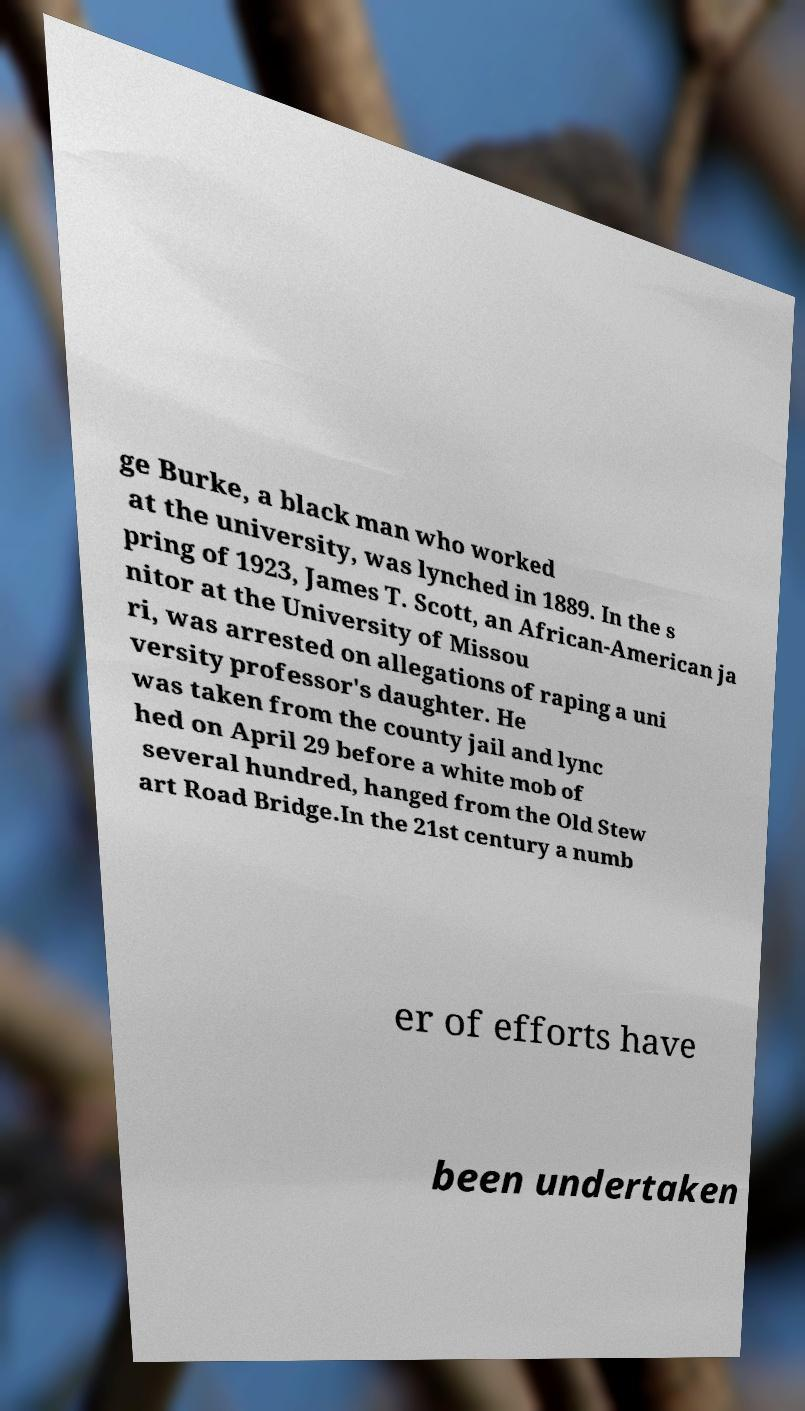Could you extract and type out the text from this image? ge Burke, a black man who worked at the university, was lynched in 1889. In the s pring of 1923, James T. Scott, an African-American ja nitor at the University of Missou ri, was arrested on allegations of raping a uni versity professor's daughter. He was taken from the county jail and lync hed on April 29 before a white mob of several hundred, hanged from the Old Stew art Road Bridge.In the 21st century a numb er of efforts have been undertaken 